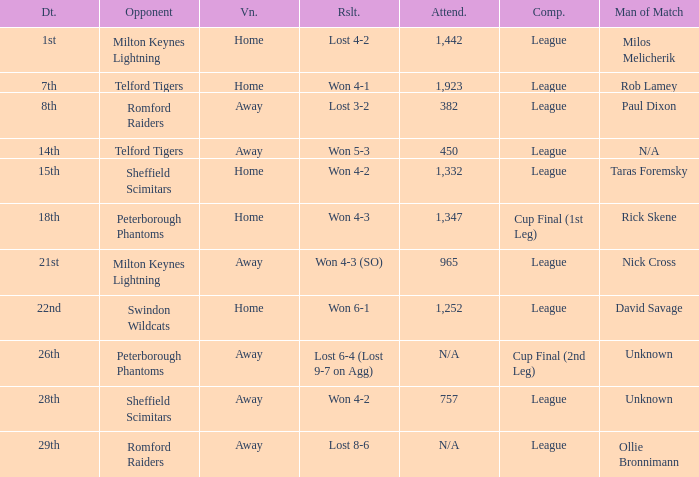On what date was the venue Away and the result was lost 6-4 (lost 9-7 on agg)? 26th. 